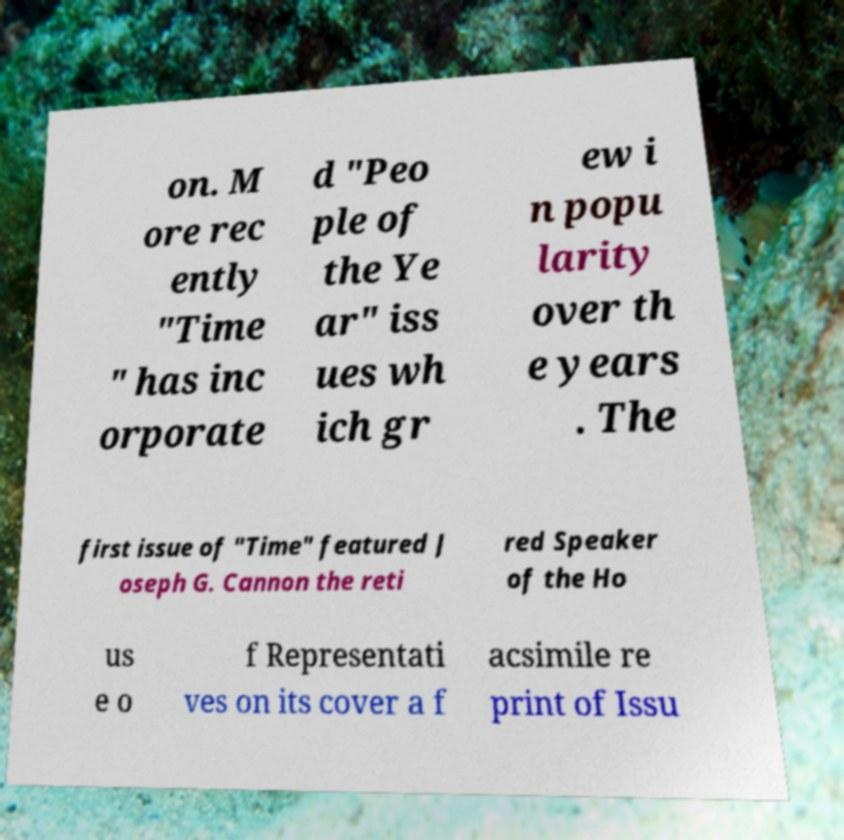I need the written content from this picture converted into text. Can you do that? on. M ore rec ently "Time " has inc orporate d "Peo ple of the Ye ar" iss ues wh ich gr ew i n popu larity over th e years . The first issue of "Time" featured J oseph G. Cannon the reti red Speaker of the Ho us e o f Representati ves on its cover a f acsimile re print of Issu 